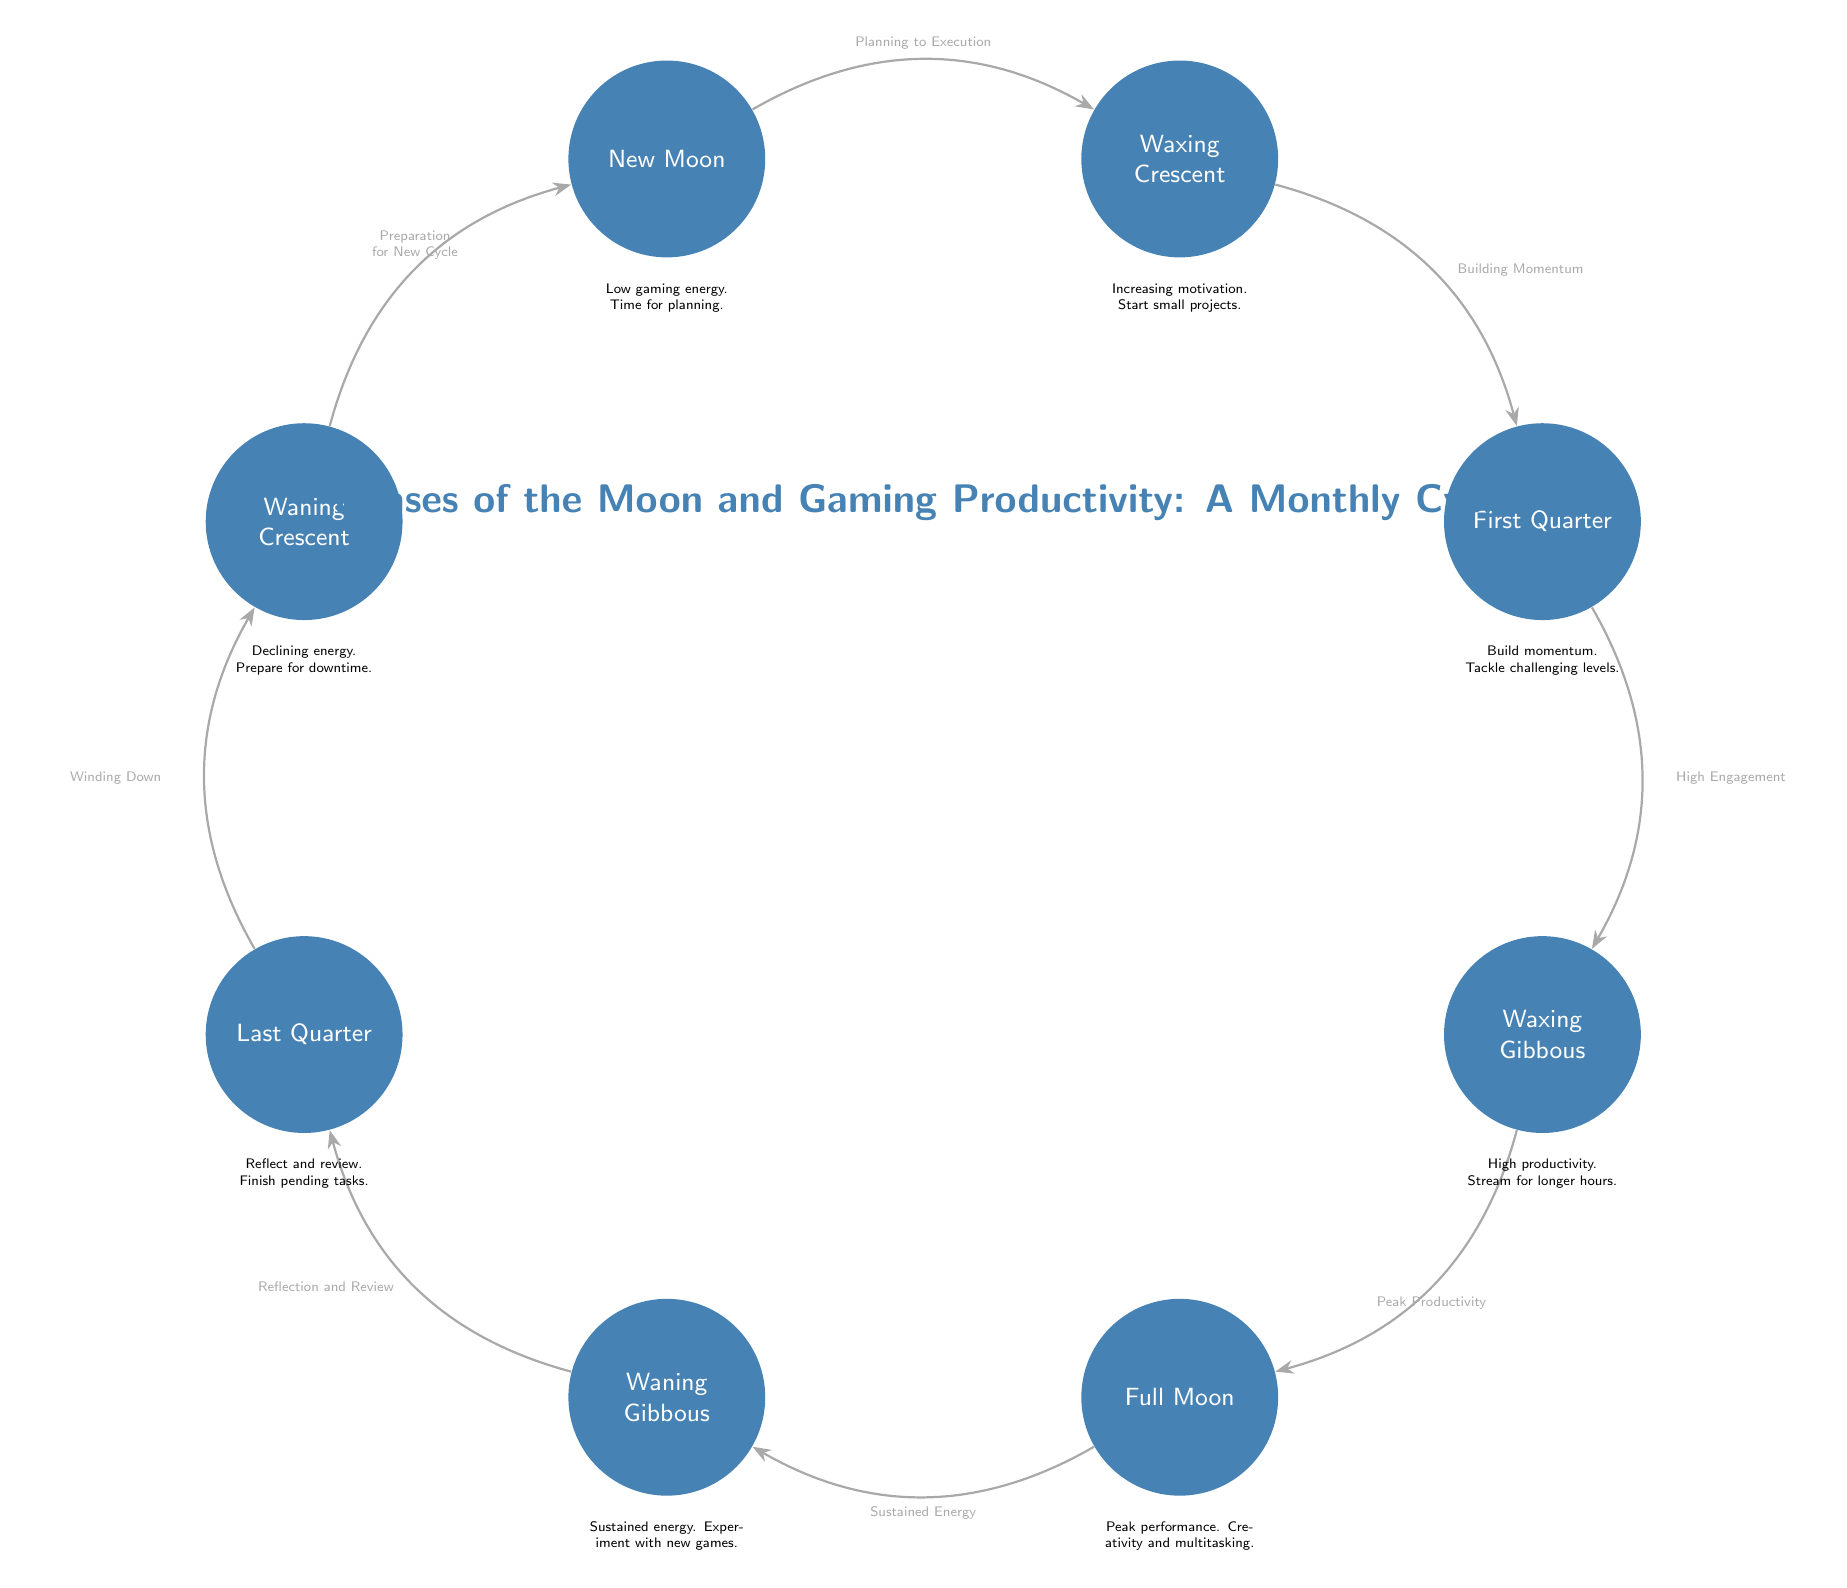What is the first phase of the moon depicted in the diagram? The diagram starts with a node labeled "New Moon," which indicates it is the first phase.
Answer: New Moon How many phases of the moon are shown in the diagram? The diagram displays a total of eight distinct phases of the moon, each represented as a separate node.
Answer: Eight What label is associated with the edge from the waxing gibbous to the full moon? The edge between the waxing gibbous and the full moon is labeled "Peak Productivity," which indicates the connection's significance in the context of gaming productivity.
Answer: Peak Productivity In which phase is gaming energy described as having "High productivity"? The phase labeled "Waxing Gibbous" corresponds to the description of having "High productivity," suggesting this timeframe is optimal for intense gaming sessions.
Answer: Waxing Gibbous What does the "Last Quarter" symbolize in the context of gaming activities? The "Last Quarter" is associated with the label "Reflect and review," signifying a time to evaluate past gaming efforts and wrap up unfinished tasks.
Answer: Reflect and review How does the "New Moon" phase influence gaming activity? The "New Moon" phase indicates "Low gaming energy. Time for planning," suggesting it is a period for strategic thinking and setting goals rather than active gaming.
Answer: Low gaming energy What activity is advised during the "Waning Crescent"? The diagram states that this phase is characterized by "Declining energy. Prepare for downtime," indicating it is a time to rest and recharge for the next cycle.
Answer: Prepare for downtime Which edge connects the first quarter to the waxing gibbous? The edge connecting the first quarter to the waxing gibbous is labeled "High Engagement," indicating an increase in motivation and participation in gaming activities.
Answer: High Engagement 